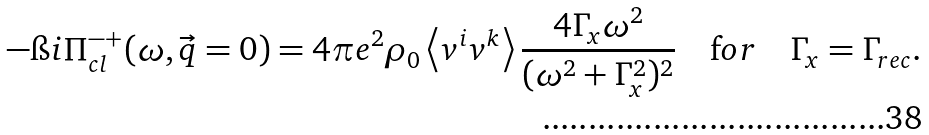Convert formula to latex. <formula><loc_0><loc_0><loc_500><loc_500>- \i i \Pi _ { c l } ^ { - + } ( \omega , { \vec { q } } = 0 ) = 4 \pi e ^ { 2 } \rho _ { 0 } \left < v ^ { i } v ^ { k } \right > \frac { 4 \Gamma _ { x } \omega ^ { 2 } } { ( \omega ^ { 2 } + \Gamma _ { x } ^ { 2 } ) ^ { 2 } } \quad { \mathrm f o r } \quad \Gamma _ { x } = \Gamma _ { r e c } .</formula> 